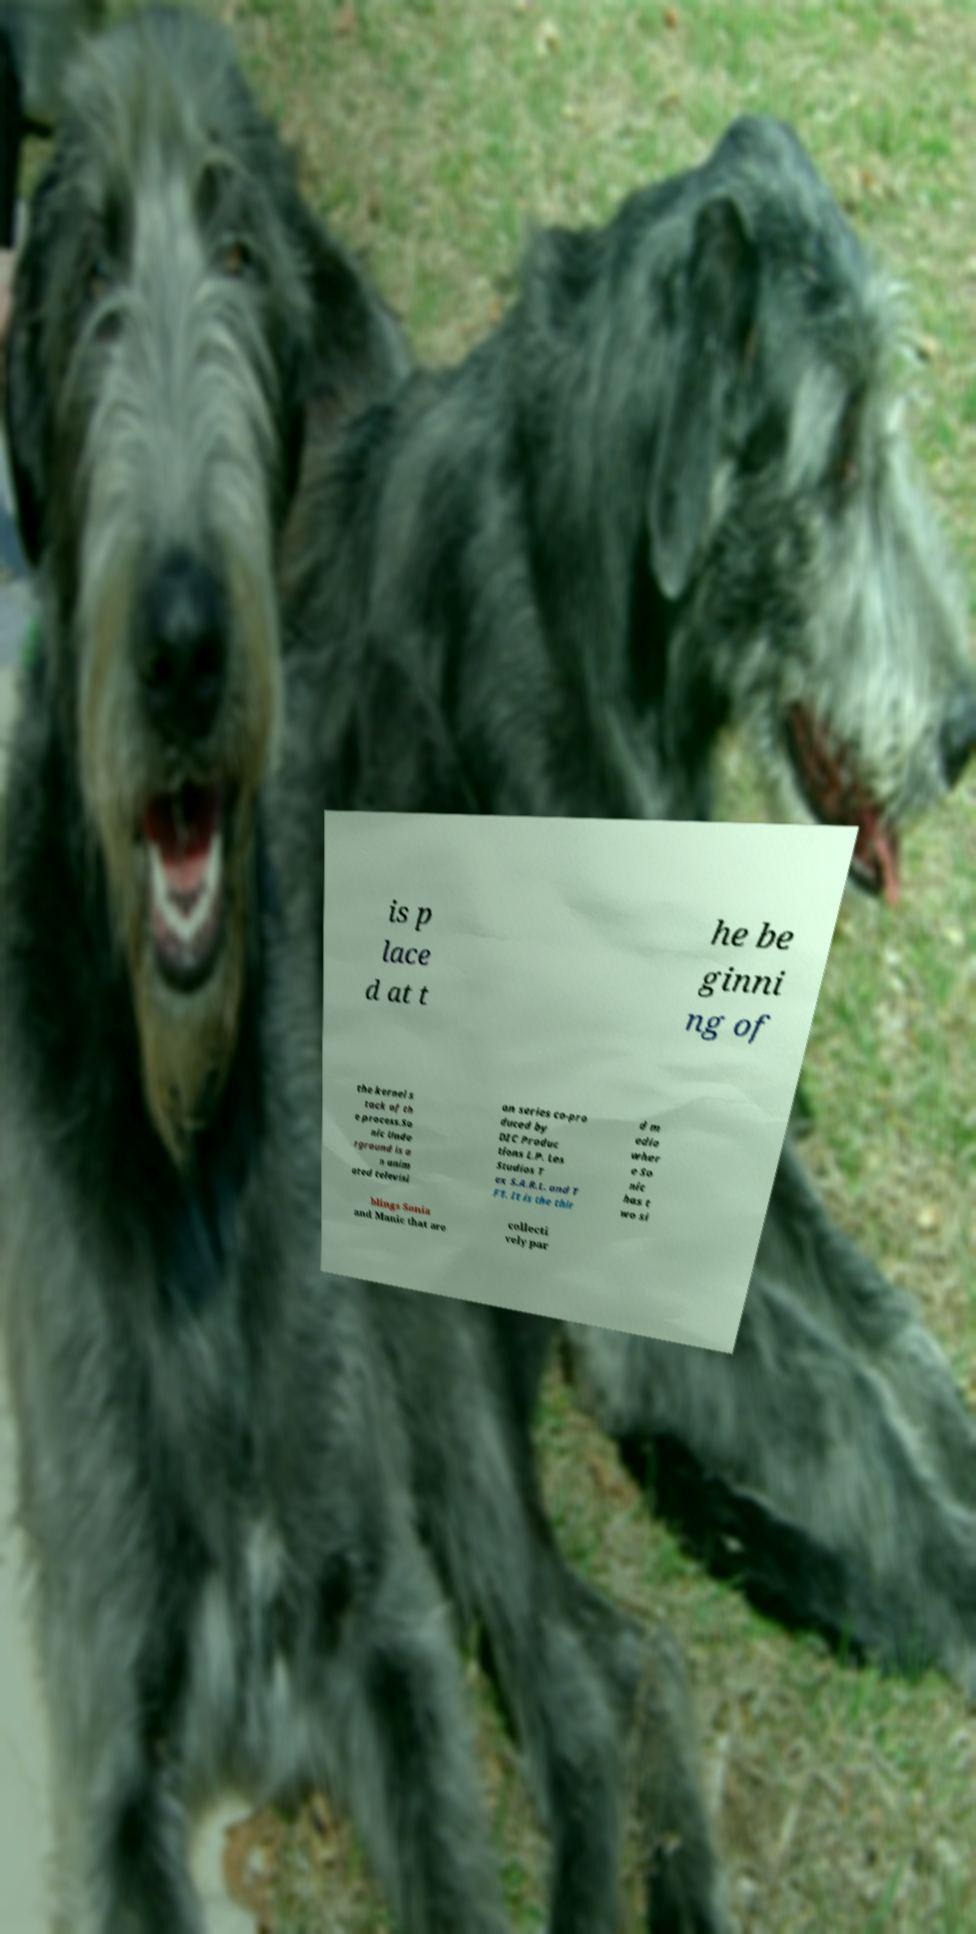Could you assist in decoding the text presented in this image and type it out clearly? is p lace d at t he be ginni ng of the kernel s tack of th e process.So nic Unde rground is a n anim ated televisi on series co-pro duced by DIC Produc tions L.P. Les Studios T ex S.A.R.L. and T F1. It is the thir d m edia wher e So nic has t wo si blings Sonia and Manic that are collecti vely par 